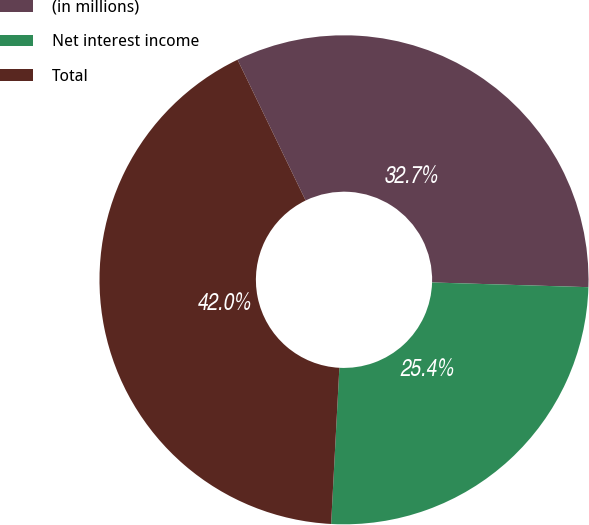Convert chart to OTSL. <chart><loc_0><loc_0><loc_500><loc_500><pie_chart><fcel>(in millions)<fcel>Net interest income<fcel>Total<nl><fcel>32.65%<fcel>25.36%<fcel>41.99%<nl></chart> 